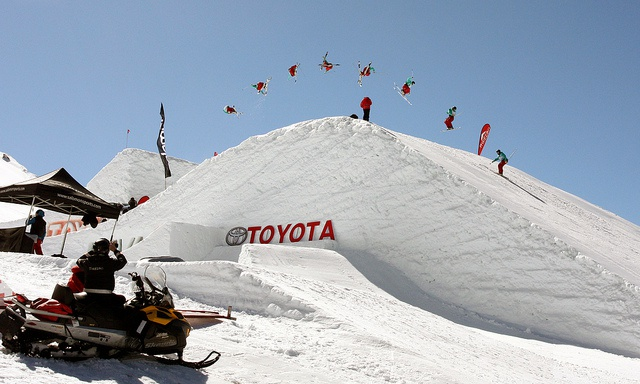Describe the objects in this image and their specific colors. I can see people in darkgray, black, gray, lightgray, and maroon tones, people in darkgray, black, maroon, and lightgray tones, people in darkgray, maroon, black, teal, and lightgray tones, people in darkgray, black, maroon, and gray tones, and people in darkgray, maroon, black, and gray tones in this image. 